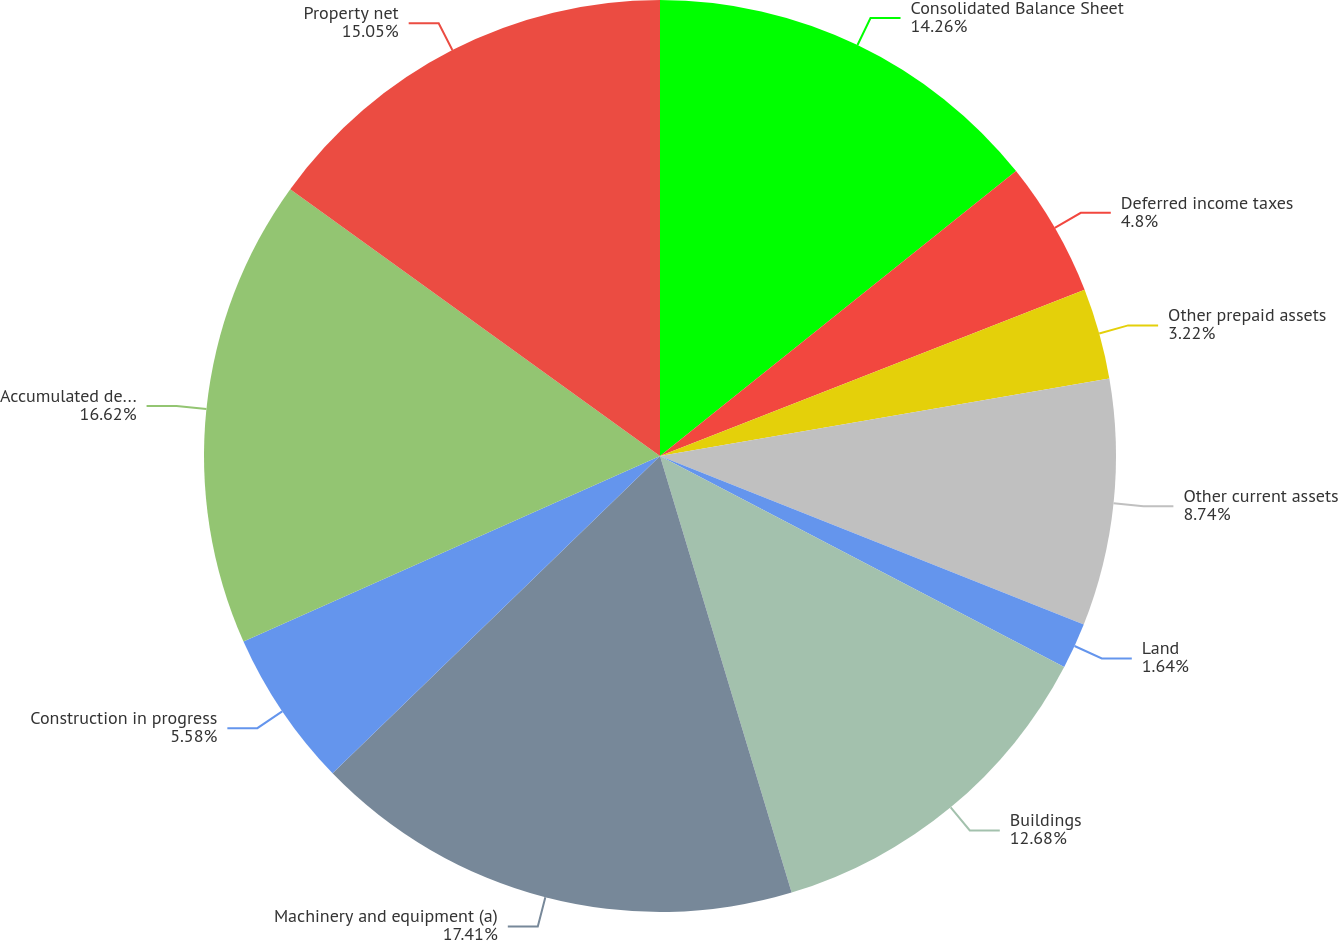Convert chart. <chart><loc_0><loc_0><loc_500><loc_500><pie_chart><fcel>Consolidated Balance Sheet<fcel>Deferred income taxes<fcel>Other prepaid assets<fcel>Other current assets<fcel>Land<fcel>Buildings<fcel>Machinery and equipment (a)<fcel>Construction in progress<fcel>Accumulated depreciation<fcel>Property net<nl><fcel>14.26%<fcel>4.8%<fcel>3.22%<fcel>8.74%<fcel>1.64%<fcel>12.68%<fcel>17.41%<fcel>5.58%<fcel>16.62%<fcel>15.05%<nl></chart> 